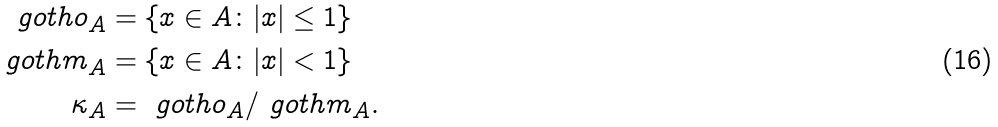Convert formula to latex. <formula><loc_0><loc_0><loc_500><loc_500>\ g o t h o _ { A } & = \{ x \in A \colon | x | \leq 1 \} \\ \ g o t h m _ { A } & = \{ x \in A \colon | x | < 1 \} \\ \kappa _ { A } & = \ g o t h o _ { A } / \ g o t h m _ { A } .</formula> 